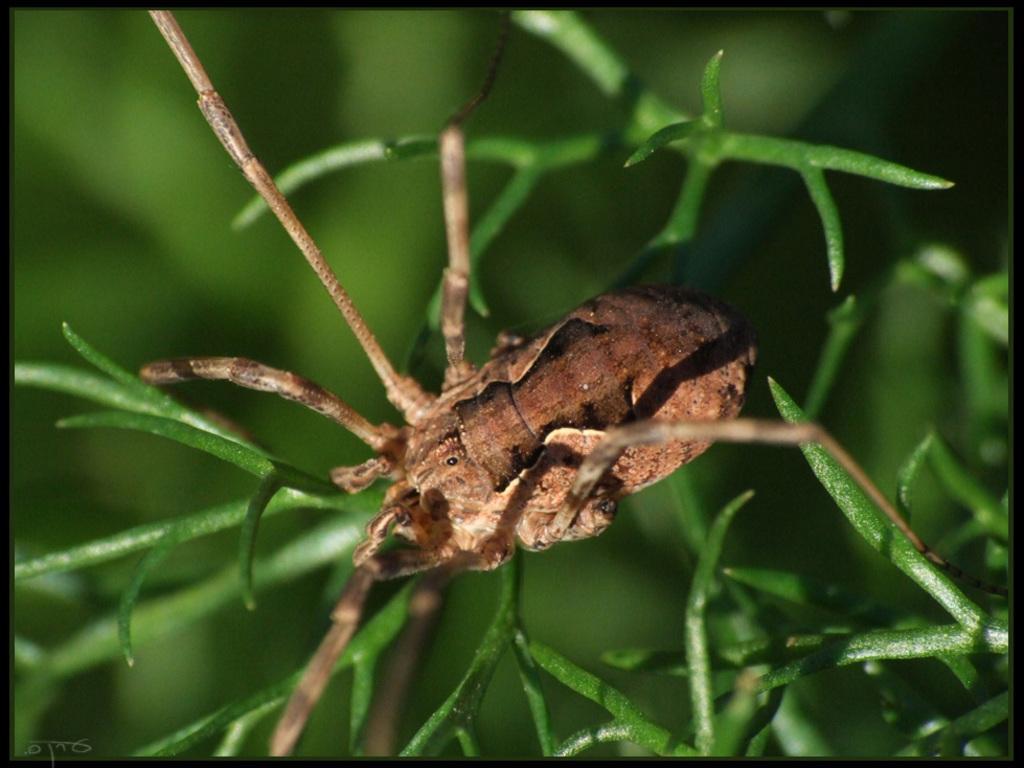Can you describe this image briefly? This is a zoomed in picture and seems to be an edited image with the black borders. In the center there is an insect on the stem of the plant. The background of the image is green in color. 